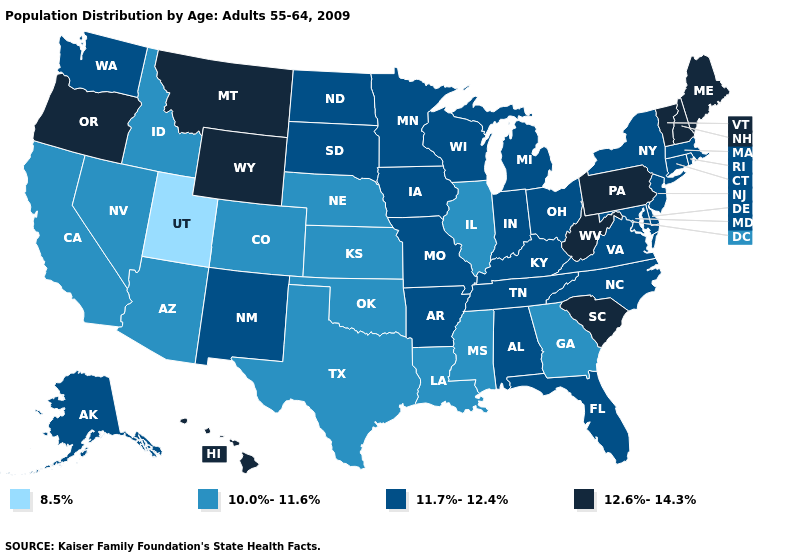Does West Virginia have the lowest value in the South?
Be succinct. No. Does Missouri have the same value as Mississippi?
Keep it brief. No. Name the states that have a value in the range 11.7%-12.4%?
Give a very brief answer. Alabama, Alaska, Arkansas, Connecticut, Delaware, Florida, Indiana, Iowa, Kentucky, Maryland, Massachusetts, Michigan, Minnesota, Missouri, New Jersey, New Mexico, New York, North Carolina, North Dakota, Ohio, Rhode Island, South Dakota, Tennessee, Virginia, Washington, Wisconsin. Name the states that have a value in the range 11.7%-12.4%?
Keep it brief. Alabama, Alaska, Arkansas, Connecticut, Delaware, Florida, Indiana, Iowa, Kentucky, Maryland, Massachusetts, Michigan, Minnesota, Missouri, New Jersey, New Mexico, New York, North Carolina, North Dakota, Ohio, Rhode Island, South Dakota, Tennessee, Virginia, Washington, Wisconsin. Does Pennsylvania have the lowest value in the Northeast?
Answer briefly. No. Which states have the lowest value in the USA?
Write a very short answer. Utah. What is the lowest value in states that border Maryland?
Keep it brief. 11.7%-12.4%. What is the lowest value in the West?
Concise answer only. 8.5%. Does Arizona have a higher value than Wyoming?
Be succinct. No. What is the lowest value in the USA?
Quick response, please. 8.5%. Does Georgia have the lowest value in the USA?
Give a very brief answer. No. How many symbols are there in the legend?
Give a very brief answer. 4. What is the lowest value in the USA?
Answer briefly. 8.5%. Does Hawaii have the highest value in the USA?
Give a very brief answer. Yes. Name the states that have a value in the range 8.5%?
Quick response, please. Utah. 